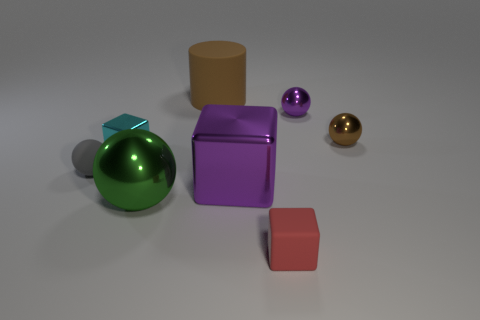Does the brown thing that is right of the purple metallic sphere have the same shape as the gray thing?
Offer a very short reply. Yes. What number of other objects are there of the same shape as the small purple metallic object?
Your answer should be compact. 3. There is a tiny matte thing on the right side of the large green thing; what is its shape?
Keep it short and to the point. Cube. Is there a small cyan cube that has the same material as the big green thing?
Ensure brevity in your answer.  Yes. Do the tiny sphere behind the brown metal object and the small metal cube have the same color?
Offer a terse response. No. The green metal thing has what size?
Keep it short and to the point. Large. Are there any spheres to the right of the small thing in front of the shiny sphere left of the red thing?
Make the answer very short. Yes. There is a red thing; how many tiny brown shiny things are on the right side of it?
Give a very brief answer. 1. What number of small matte spheres are the same color as the matte cylinder?
Offer a very short reply. 0. How many things are either things right of the tiny purple metallic sphere or large metallic objects that are to the right of the big brown rubber thing?
Your answer should be compact. 2. 